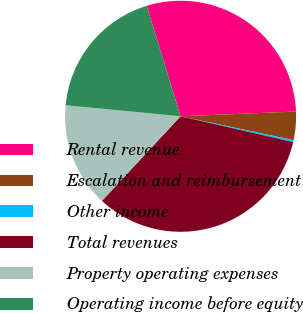Convert chart. <chart><loc_0><loc_0><loc_500><loc_500><pie_chart><fcel>Rental revenue<fcel>Escalation and reimbursement<fcel>Other income<fcel>Total revenues<fcel>Property operating expenses<fcel>Operating income before equity<nl><fcel>29.09%<fcel>3.97%<fcel>0.27%<fcel>33.33%<fcel>14.6%<fcel>18.74%<nl></chart> 